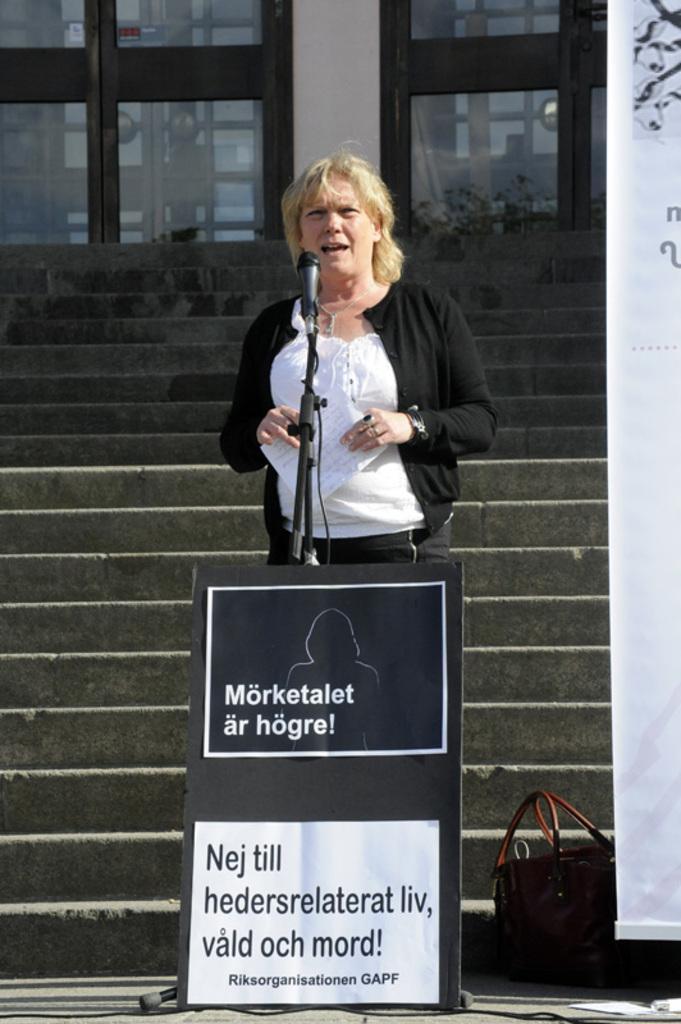Can you describe this image briefly? This image is clicked outside. There is a woman standing. In front of her there is a mic and a board. She is wearing white and black color dress. Behind her there are stairs and beside her there is a bag and a banner on the right side. On the top the doors. 